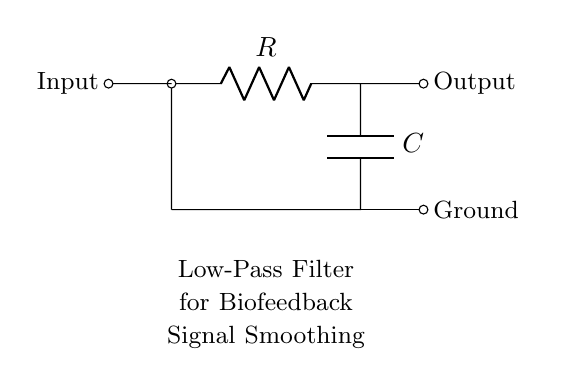What type of filter is represented in this circuit? This circuit diagram depicts a low-pass filter, designed to allow low-frequency signals to pass through while attenuating higher-frequency ones. The presence of a resistor and capacitor in the arrangement confirms this as a fundamental low-pass filter.
Answer: low-pass filter What are the components used in this circuit? The circuit consists of a resistor (R) and a capacitor (C). These components are essential for creating the filtering effect. The labels in the circuit diagram clearly identify them as "R" for the resistor and "C" for the capacitor.
Answer: resistor and capacitor What is the primary application of this filter? The circuit is explicitly labeled for biofeedback signal smoothing, indicating its purpose in therapy sessions to help refine or reduce noise in biofeedback signals for better therapeutic outcomes.
Answer: biofeedback signal smoothing How does the filter affect high-frequency signals? The low-pass filter attenuates high-frequency signals, reducing their amplitude so they do not appear significantly at the output. This effect is fundamental to the design, as the capacitor offers high impedance to high frequencies, causing them to be diminished in the output.
Answer: attenuates Where is the ground connection in the circuit? The ground connection can be identified at the bottom of the circuit where the output of the capacitor connects to the ground line. This is a crucial part of the circuit that provides a reference point for voltage levels and stable operation.
Answer: bottom of the circuit What happens to the output signal if the resistance increases? Increasing the resistance tends to lower the cutoff frequency of the filter, allowing fewer high-frequency signals through and resulting in a smoother output signal. The relationship between resistance and frequency is determined by the RC time constant, which is affected directly by changes in resistance.
Answer: smoother output signal What does the output label indicate in this circuit? The output label indicates the point at which the filtered signal can be observed or measured after passing through the low-pass filter. This is essential for determining how effectively the filter has smoothed the input biofeedback signals.
Answer: filtered signal output 